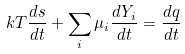<formula> <loc_0><loc_0><loc_500><loc_500>k T \frac { d s } { d t } + \sum _ { i } \mu _ { i } \frac { d Y _ { i } } { d t } = \frac { d q } { d t }</formula> 